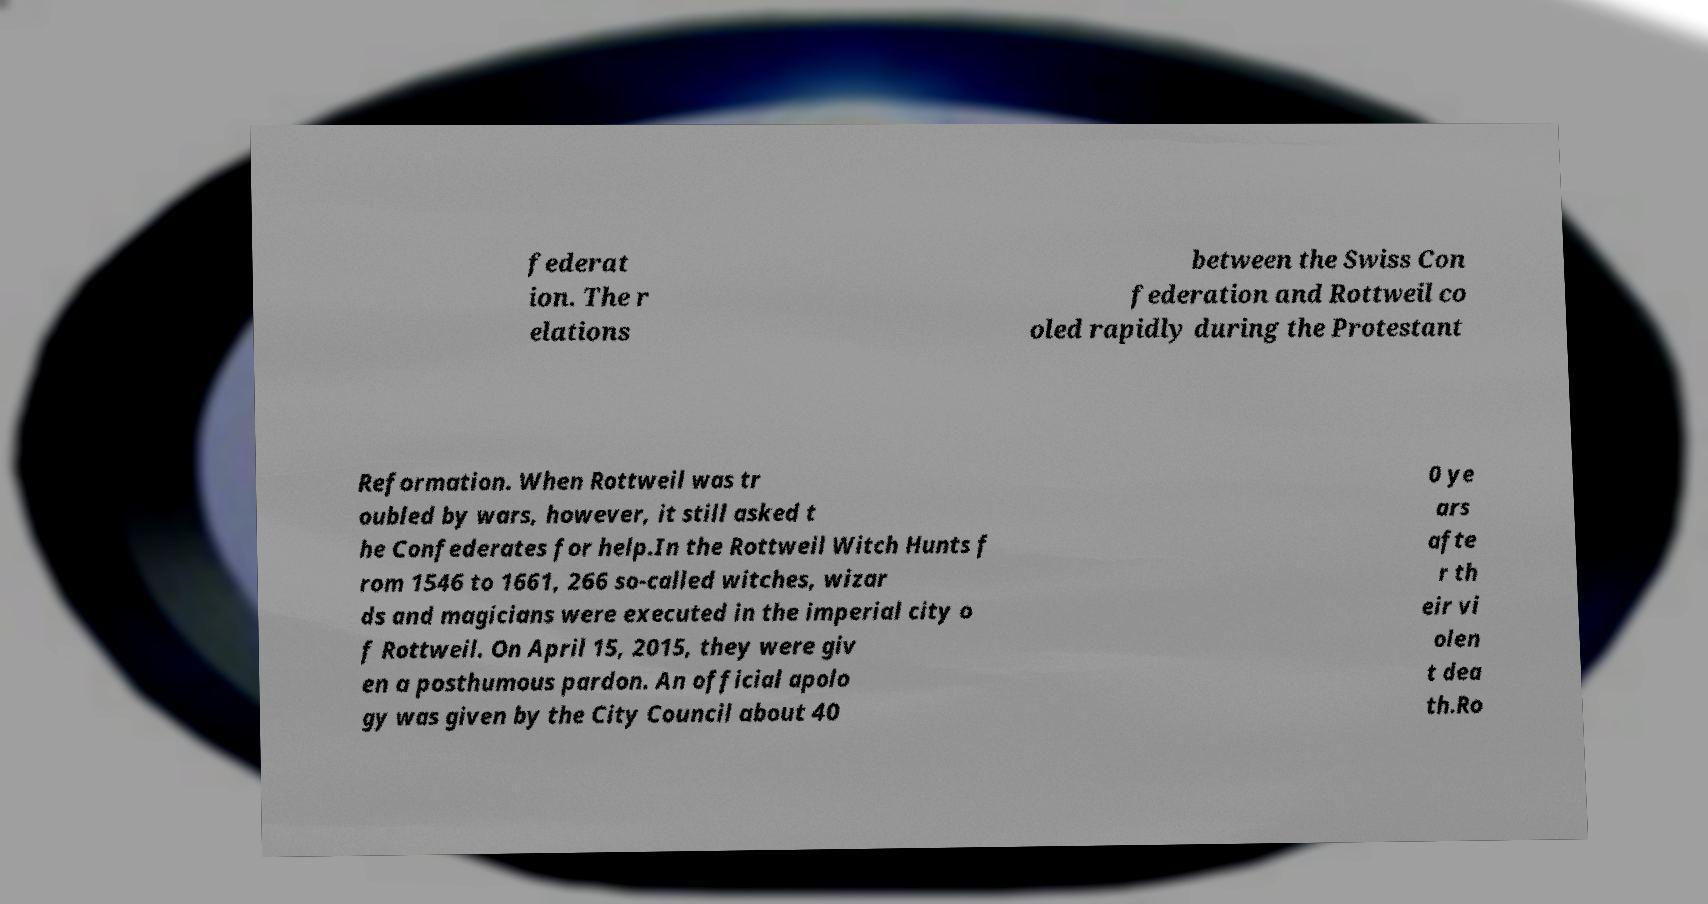What messages or text are displayed in this image? I need them in a readable, typed format. federat ion. The r elations between the Swiss Con federation and Rottweil co oled rapidly during the Protestant Reformation. When Rottweil was tr oubled by wars, however, it still asked t he Confederates for help.In the Rottweil Witch Hunts f rom 1546 to 1661, 266 so-called witches, wizar ds and magicians were executed in the imperial city o f Rottweil. On April 15, 2015, they were giv en a posthumous pardon. An official apolo gy was given by the City Council about 40 0 ye ars afte r th eir vi olen t dea th.Ro 